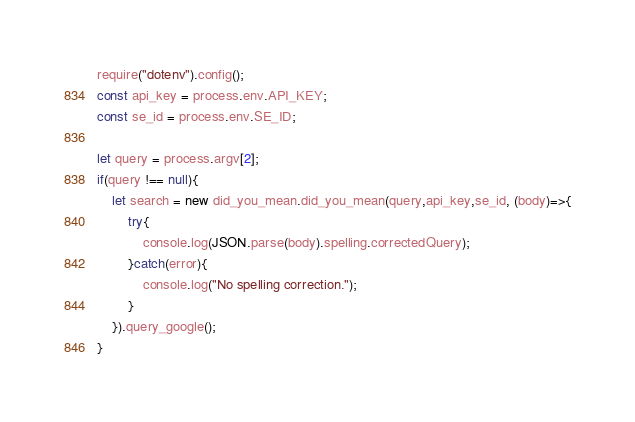<code> <loc_0><loc_0><loc_500><loc_500><_JavaScript_>require("dotenv").config();
const api_key = process.env.API_KEY;
const se_id = process.env.SE_ID;

let query = process.argv[2];
if(query !== null){
    let search = new did_you_mean.did_you_mean(query,api_key,se_id, (body)=>{
        try{
            console.log(JSON.parse(body).spelling.correctedQuery);
        }catch(error){
            console.log("No spelling correction.");
        }
    }).query_google();
}</code> 